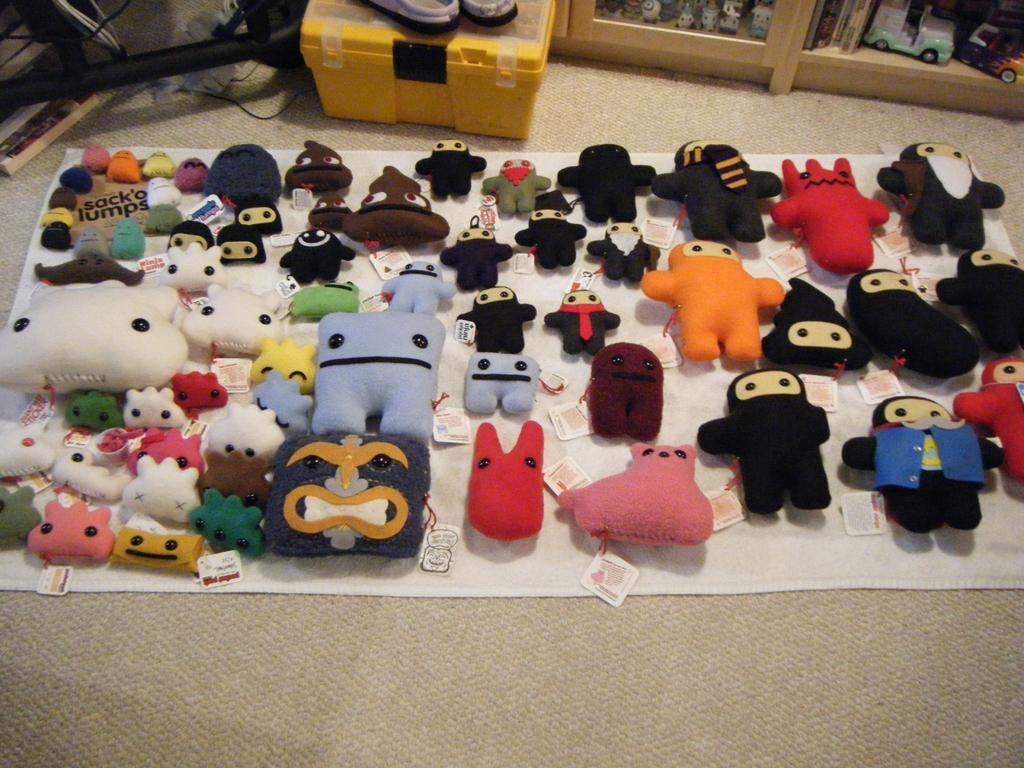What type of objects are present in the image with tags? There are toys with tags in the image. What is the toys placed on? The toys are placed on a cloth and a box. What else can be seen in the image besides the toys? Wires are present in the image. What is the price of the metal rainstorm depicted in the image? There is no metal rainstorm present in the image, and therefore no price can be determined. 